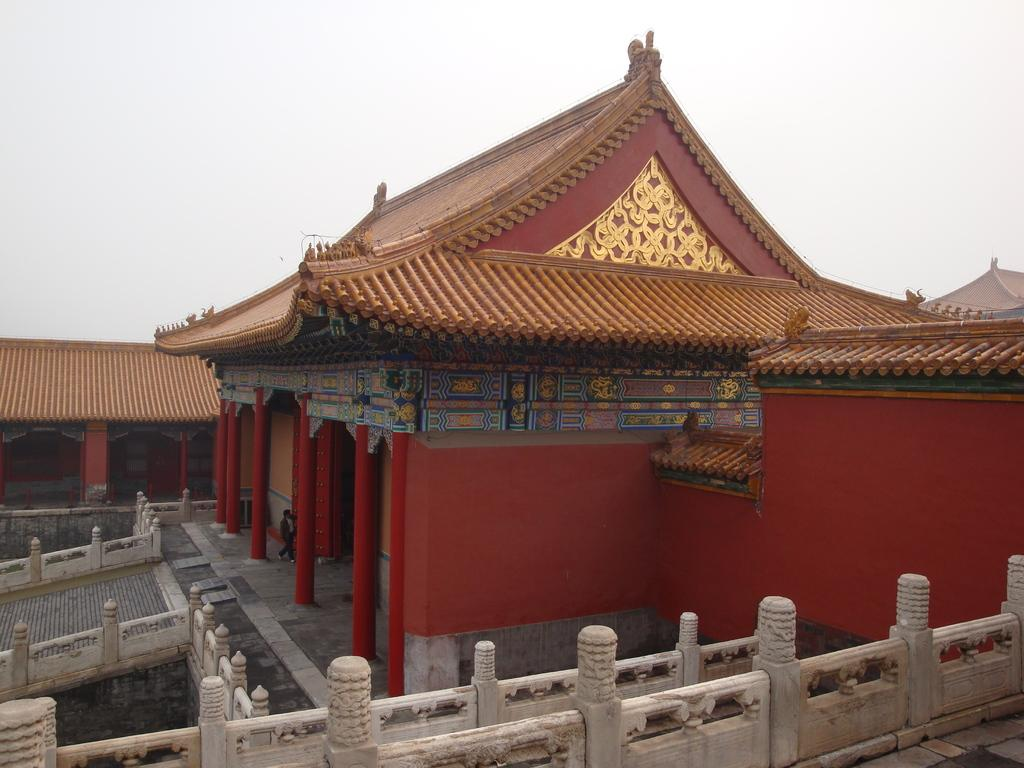What type of building is depicted in the image? There is a building in the image that resembles a palace. Can you describe any activity happening in the image? There is a person walking in the image. What feature surrounds the palace in the image? There is a compound wall surrounding the palace in the image. What is visible at the top of the image? The sky is visible at the top of the image. What type of popcorn is being served at the palace in the image? There is no popcorn present in the image; it is a palace-like building with a person walking and a compound wall surrounding it. What type of art can be seen on the arch in the image? There is no arch present in the image, so it is not possible to determine if any art is displayed on it. 